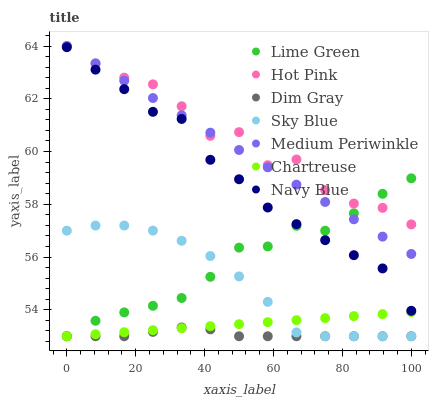Does Dim Gray have the minimum area under the curve?
Answer yes or no. Yes. Does Hot Pink have the maximum area under the curve?
Answer yes or no. Yes. Does Navy Blue have the minimum area under the curve?
Answer yes or no. No. Does Navy Blue have the maximum area under the curve?
Answer yes or no. No. Is Chartreuse the smoothest?
Answer yes or no. Yes. Is Hot Pink the roughest?
Answer yes or no. Yes. Is Navy Blue the smoothest?
Answer yes or no. No. Is Navy Blue the roughest?
Answer yes or no. No. Does Dim Gray have the lowest value?
Answer yes or no. Yes. Does Navy Blue have the lowest value?
Answer yes or no. No. Does Medium Periwinkle have the highest value?
Answer yes or no. Yes. Does Navy Blue have the highest value?
Answer yes or no. No. Is Dim Gray less than Medium Periwinkle?
Answer yes or no. Yes. Is Medium Periwinkle greater than Sky Blue?
Answer yes or no. Yes. Does Lime Green intersect Medium Periwinkle?
Answer yes or no. Yes. Is Lime Green less than Medium Periwinkle?
Answer yes or no. No. Is Lime Green greater than Medium Periwinkle?
Answer yes or no. No. Does Dim Gray intersect Medium Periwinkle?
Answer yes or no. No. 